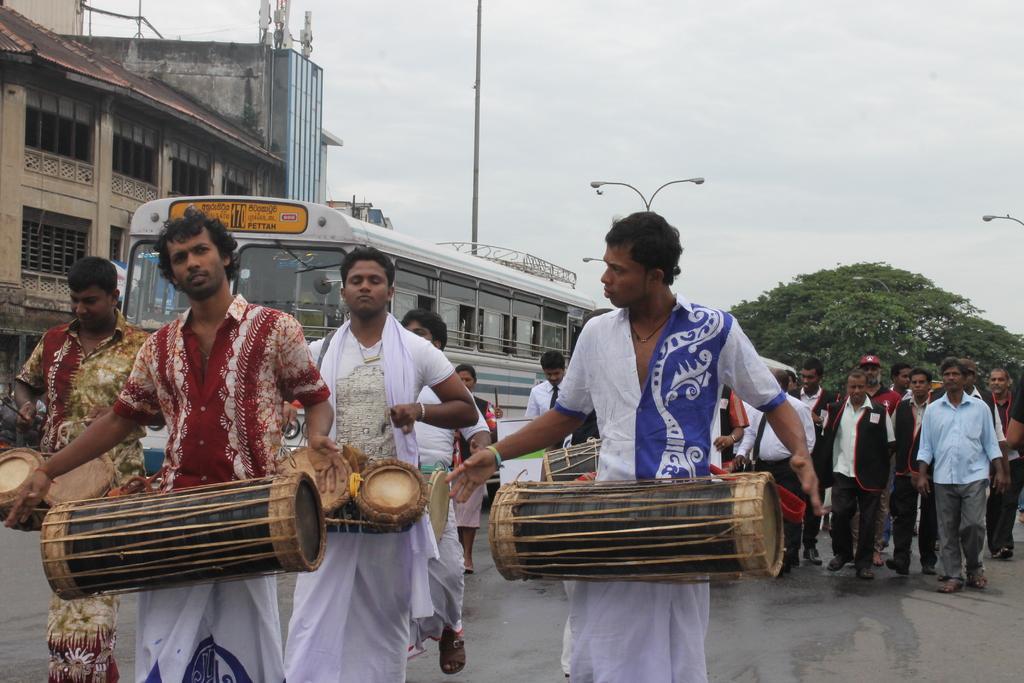In one or two sentences, can you explain what this image depicts? Here some people are playing some musical instrument and walking on the road. Behind them a group of people are walking and also a bus is there. In the background there is sky and a tree. We can see a building over the left side. 